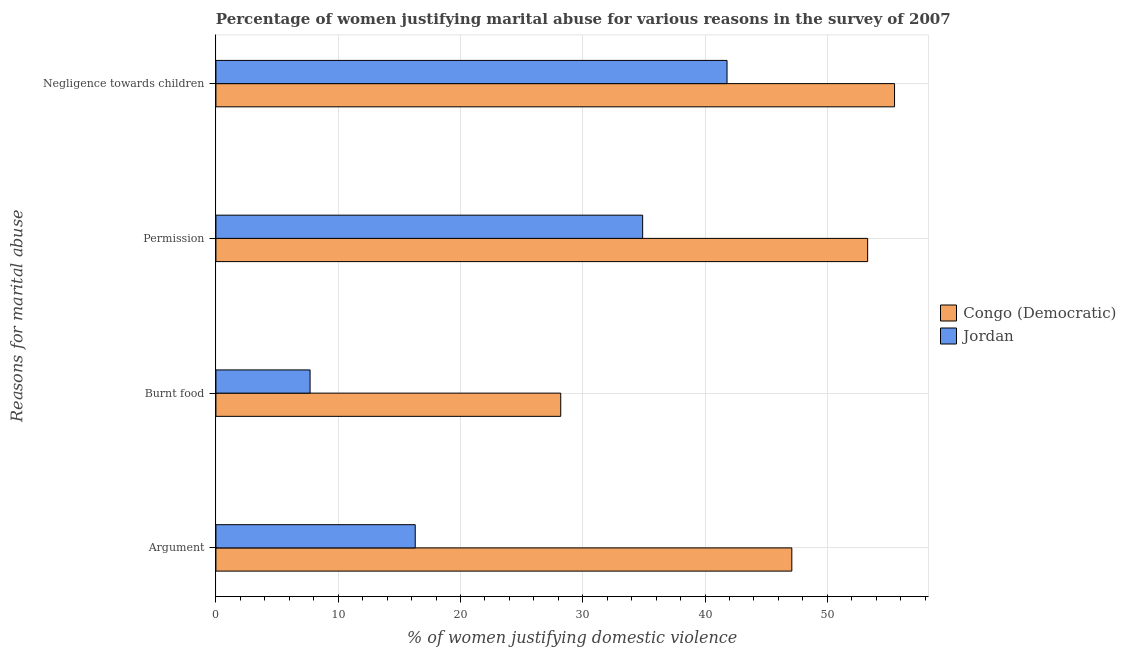Are the number of bars on each tick of the Y-axis equal?
Make the answer very short. Yes. How many bars are there on the 2nd tick from the top?
Your response must be concise. 2. How many bars are there on the 2nd tick from the bottom?
Your answer should be compact. 2. What is the label of the 4th group of bars from the top?
Your answer should be very brief. Argument. What is the percentage of women justifying abuse in the case of an argument in Jordan?
Provide a succinct answer. 16.3. Across all countries, what is the maximum percentage of women justifying abuse for going without permission?
Provide a short and direct response. 53.3. Across all countries, what is the minimum percentage of women justifying abuse for going without permission?
Provide a short and direct response. 34.9. In which country was the percentage of women justifying abuse for going without permission maximum?
Provide a short and direct response. Congo (Democratic). In which country was the percentage of women justifying abuse in the case of an argument minimum?
Offer a terse response. Jordan. What is the total percentage of women justifying abuse for going without permission in the graph?
Offer a terse response. 88.2. What is the difference between the percentage of women justifying abuse for going without permission in Jordan and that in Congo (Democratic)?
Your answer should be very brief. -18.4. What is the difference between the percentage of women justifying abuse for burning food in Jordan and the percentage of women justifying abuse for going without permission in Congo (Democratic)?
Your answer should be compact. -45.6. What is the average percentage of women justifying abuse for burning food per country?
Provide a short and direct response. 17.95. What is the difference between the percentage of women justifying abuse for going without permission and percentage of women justifying abuse for burning food in Jordan?
Your answer should be very brief. 27.2. In how many countries, is the percentage of women justifying abuse in the case of an argument greater than 44 %?
Ensure brevity in your answer.  1. What is the ratio of the percentage of women justifying abuse for showing negligence towards children in Jordan to that in Congo (Democratic)?
Your response must be concise. 0.75. Is the percentage of women justifying abuse for going without permission in Jordan less than that in Congo (Democratic)?
Offer a terse response. Yes. What is the difference between the highest and the second highest percentage of women justifying abuse for showing negligence towards children?
Provide a short and direct response. 13.7. What is the difference between the highest and the lowest percentage of women justifying abuse for burning food?
Your response must be concise. 20.5. In how many countries, is the percentage of women justifying abuse for going without permission greater than the average percentage of women justifying abuse for going without permission taken over all countries?
Ensure brevity in your answer.  1. Is it the case that in every country, the sum of the percentage of women justifying abuse for showing negligence towards children and percentage of women justifying abuse for burning food is greater than the sum of percentage of women justifying abuse for going without permission and percentage of women justifying abuse in the case of an argument?
Offer a very short reply. No. What does the 2nd bar from the top in Argument represents?
Give a very brief answer. Congo (Democratic). What does the 1st bar from the bottom in Burnt food represents?
Provide a short and direct response. Congo (Democratic). Is it the case that in every country, the sum of the percentage of women justifying abuse in the case of an argument and percentage of women justifying abuse for burning food is greater than the percentage of women justifying abuse for going without permission?
Provide a succinct answer. No. How many bars are there?
Give a very brief answer. 8. Are all the bars in the graph horizontal?
Provide a succinct answer. Yes. How many countries are there in the graph?
Provide a succinct answer. 2. What is the difference between two consecutive major ticks on the X-axis?
Make the answer very short. 10. Are the values on the major ticks of X-axis written in scientific E-notation?
Your answer should be compact. No. Does the graph contain any zero values?
Your response must be concise. No. How are the legend labels stacked?
Your answer should be compact. Vertical. What is the title of the graph?
Provide a succinct answer. Percentage of women justifying marital abuse for various reasons in the survey of 2007. Does "Cote d'Ivoire" appear as one of the legend labels in the graph?
Your response must be concise. No. What is the label or title of the X-axis?
Your response must be concise. % of women justifying domestic violence. What is the label or title of the Y-axis?
Make the answer very short. Reasons for marital abuse. What is the % of women justifying domestic violence in Congo (Democratic) in Argument?
Give a very brief answer. 47.1. What is the % of women justifying domestic violence of Jordan in Argument?
Your answer should be very brief. 16.3. What is the % of women justifying domestic violence in Congo (Democratic) in Burnt food?
Keep it short and to the point. 28.2. What is the % of women justifying domestic violence of Congo (Democratic) in Permission?
Give a very brief answer. 53.3. What is the % of women justifying domestic violence of Jordan in Permission?
Make the answer very short. 34.9. What is the % of women justifying domestic violence in Congo (Democratic) in Negligence towards children?
Give a very brief answer. 55.5. What is the % of women justifying domestic violence in Jordan in Negligence towards children?
Give a very brief answer. 41.8. Across all Reasons for marital abuse, what is the maximum % of women justifying domestic violence of Congo (Democratic)?
Your answer should be compact. 55.5. Across all Reasons for marital abuse, what is the maximum % of women justifying domestic violence in Jordan?
Your answer should be compact. 41.8. Across all Reasons for marital abuse, what is the minimum % of women justifying domestic violence of Congo (Democratic)?
Give a very brief answer. 28.2. What is the total % of women justifying domestic violence in Congo (Democratic) in the graph?
Make the answer very short. 184.1. What is the total % of women justifying domestic violence of Jordan in the graph?
Ensure brevity in your answer.  100.7. What is the difference between the % of women justifying domestic violence in Congo (Democratic) in Argument and that in Burnt food?
Offer a terse response. 18.9. What is the difference between the % of women justifying domestic violence in Congo (Democratic) in Argument and that in Permission?
Ensure brevity in your answer.  -6.2. What is the difference between the % of women justifying domestic violence of Jordan in Argument and that in Permission?
Provide a succinct answer. -18.6. What is the difference between the % of women justifying domestic violence of Congo (Democratic) in Argument and that in Negligence towards children?
Keep it short and to the point. -8.4. What is the difference between the % of women justifying domestic violence of Jordan in Argument and that in Negligence towards children?
Offer a terse response. -25.5. What is the difference between the % of women justifying domestic violence in Congo (Democratic) in Burnt food and that in Permission?
Make the answer very short. -25.1. What is the difference between the % of women justifying domestic violence of Jordan in Burnt food and that in Permission?
Your response must be concise. -27.2. What is the difference between the % of women justifying domestic violence of Congo (Democratic) in Burnt food and that in Negligence towards children?
Your response must be concise. -27.3. What is the difference between the % of women justifying domestic violence in Jordan in Burnt food and that in Negligence towards children?
Your response must be concise. -34.1. What is the difference between the % of women justifying domestic violence of Congo (Democratic) in Permission and that in Negligence towards children?
Give a very brief answer. -2.2. What is the difference between the % of women justifying domestic violence in Congo (Democratic) in Argument and the % of women justifying domestic violence in Jordan in Burnt food?
Your response must be concise. 39.4. What is the difference between the % of women justifying domestic violence in Congo (Democratic) in Argument and the % of women justifying domestic violence in Jordan in Negligence towards children?
Ensure brevity in your answer.  5.3. What is the difference between the % of women justifying domestic violence in Congo (Democratic) in Burnt food and the % of women justifying domestic violence in Jordan in Permission?
Your response must be concise. -6.7. What is the difference between the % of women justifying domestic violence in Congo (Democratic) in Permission and the % of women justifying domestic violence in Jordan in Negligence towards children?
Your response must be concise. 11.5. What is the average % of women justifying domestic violence of Congo (Democratic) per Reasons for marital abuse?
Your answer should be very brief. 46.02. What is the average % of women justifying domestic violence of Jordan per Reasons for marital abuse?
Give a very brief answer. 25.18. What is the difference between the % of women justifying domestic violence of Congo (Democratic) and % of women justifying domestic violence of Jordan in Argument?
Offer a very short reply. 30.8. What is the difference between the % of women justifying domestic violence in Congo (Democratic) and % of women justifying domestic violence in Jordan in Burnt food?
Provide a short and direct response. 20.5. What is the difference between the % of women justifying domestic violence in Congo (Democratic) and % of women justifying domestic violence in Jordan in Negligence towards children?
Provide a short and direct response. 13.7. What is the ratio of the % of women justifying domestic violence in Congo (Democratic) in Argument to that in Burnt food?
Your response must be concise. 1.67. What is the ratio of the % of women justifying domestic violence of Jordan in Argument to that in Burnt food?
Keep it short and to the point. 2.12. What is the ratio of the % of women justifying domestic violence in Congo (Democratic) in Argument to that in Permission?
Give a very brief answer. 0.88. What is the ratio of the % of women justifying domestic violence of Jordan in Argument to that in Permission?
Ensure brevity in your answer.  0.47. What is the ratio of the % of women justifying domestic violence in Congo (Democratic) in Argument to that in Negligence towards children?
Offer a terse response. 0.85. What is the ratio of the % of women justifying domestic violence in Jordan in Argument to that in Negligence towards children?
Make the answer very short. 0.39. What is the ratio of the % of women justifying domestic violence in Congo (Democratic) in Burnt food to that in Permission?
Your answer should be compact. 0.53. What is the ratio of the % of women justifying domestic violence in Jordan in Burnt food to that in Permission?
Give a very brief answer. 0.22. What is the ratio of the % of women justifying domestic violence of Congo (Democratic) in Burnt food to that in Negligence towards children?
Your answer should be very brief. 0.51. What is the ratio of the % of women justifying domestic violence of Jordan in Burnt food to that in Negligence towards children?
Offer a terse response. 0.18. What is the ratio of the % of women justifying domestic violence in Congo (Democratic) in Permission to that in Negligence towards children?
Your response must be concise. 0.96. What is the ratio of the % of women justifying domestic violence in Jordan in Permission to that in Negligence towards children?
Provide a succinct answer. 0.83. What is the difference between the highest and the second highest % of women justifying domestic violence in Jordan?
Your answer should be compact. 6.9. What is the difference between the highest and the lowest % of women justifying domestic violence in Congo (Democratic)?
Ensure brevity in your answer.  27.3. What is the difference between the highest and the lowest % of women justifying domestic violence of Jordan?
Keep it short and to the point. 34.1. 